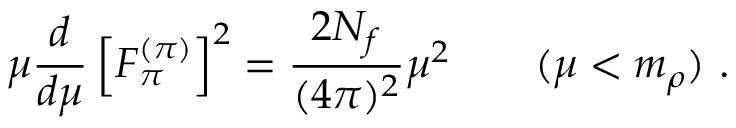<formula> <loc_0><loc_0><loc_500><loc_500>\mu \frac { d } { d \mu } \left [ F _ { \pi } ^ { ( \pi ) } \right ] ^ { 2 } = \frac { 2 N _ { f } } { ( 4 \pi ) ^ { 2 } } \mu ^ { 2 } \quad ( \mu < m _ { \rho } ) \ .</formula> 